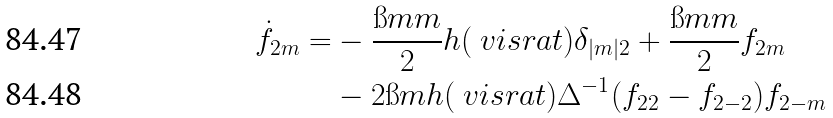<formula> <loc_0><loc_0><loc_500><loc_500>\dot { f } _ { 2 m } = & - \frac { \i m m } { 2 } h ( \ v i s r a t ) \delta _ { | m | 2 } + \frac { \i m m } { 2 } f _ { 2 m } \\ & - 2 \i m h ( \ v i s r a t ) \Delta ^ { - 1 } ( f _ { 2 2 } - f _ { 2 - 2 } ) f _ { 2 - m }</formula> 